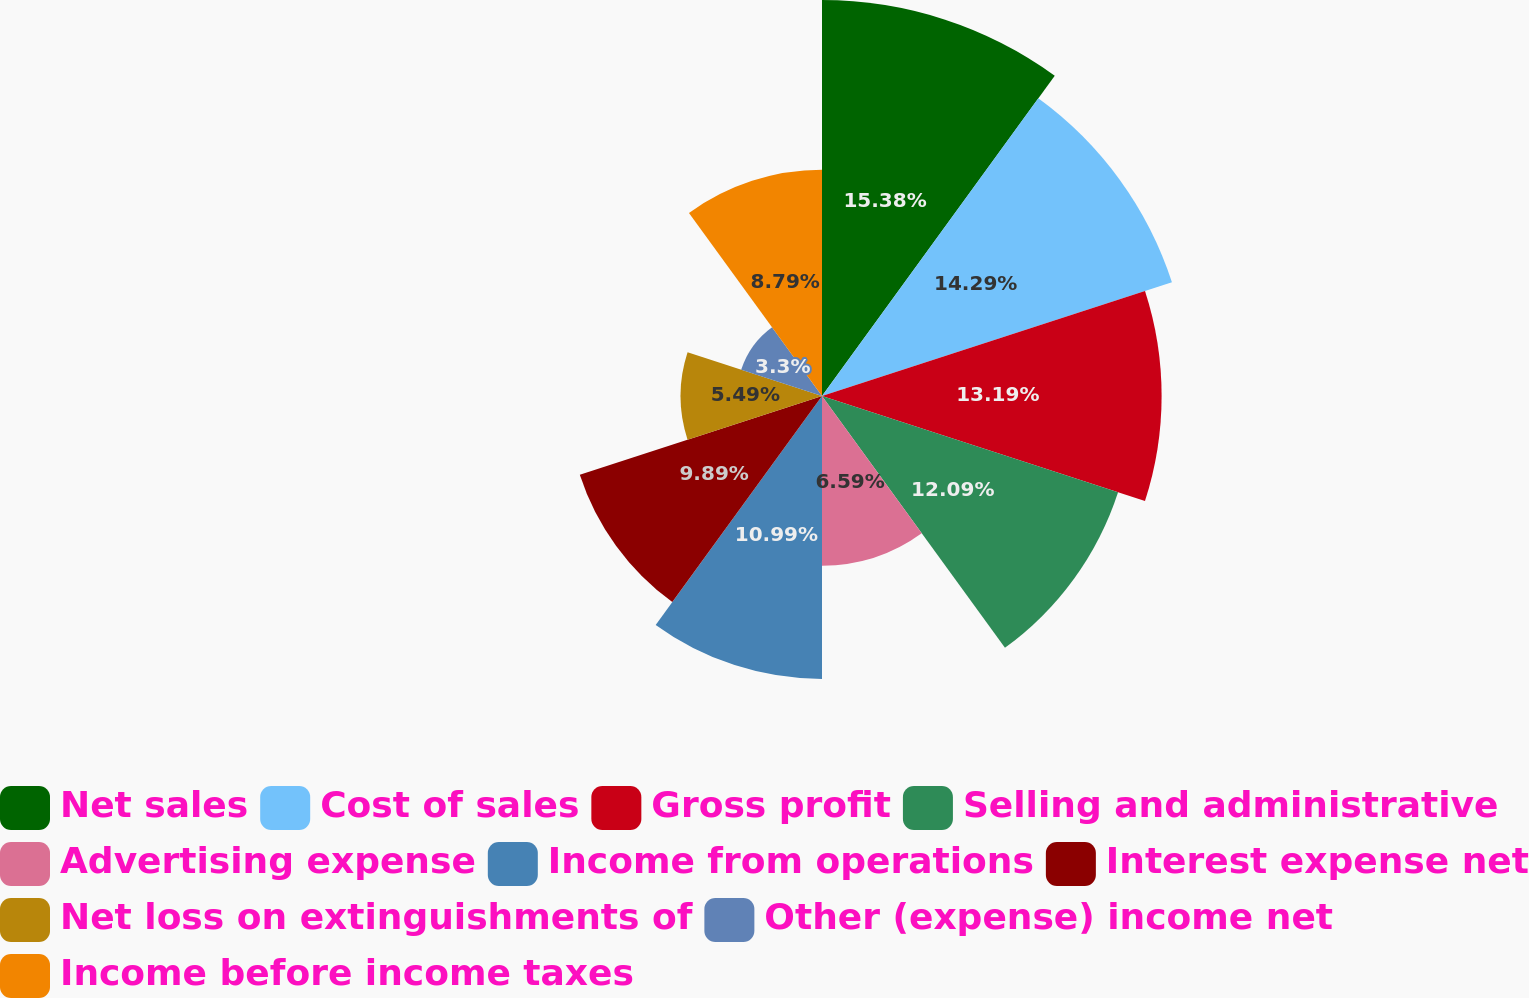<chart> <loc_0><loc_0><loc_500><loc_500><pie_chart><fcel>Net sales<fcel>Cost of sales<fcel>Gross profit<fcel>Selling and administrative<fcel>Advertising expense<fcel>Income from operations<fcel>Interest expense net<fcel>Net loss on extinguishments of<fcel>Other (expense) income net<fcel>Income before income taxes<nl><fcel>15.38%<fcel>14.29%<fcel>13.19%<fcel>12.09%<fcel>6.59%<fcel>10.99%<fcel>9.89%<fcel>5.49%<fcel>3.3%<fcel>8.79%<nl></chart> 